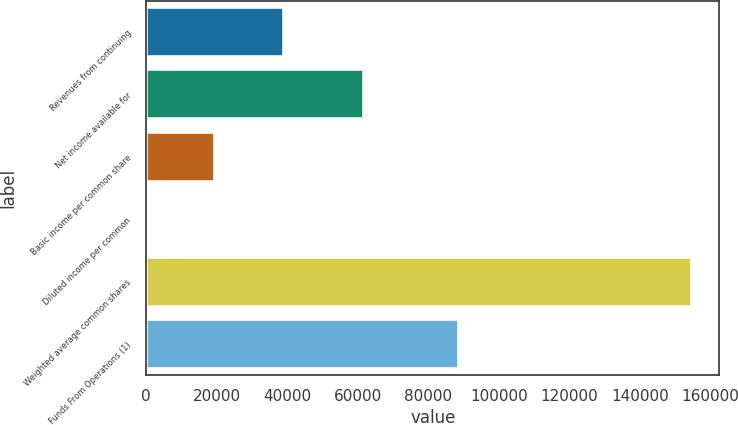Convert chart. <chart><loc_0><loc_0><loc_500><loc_500><bar_chart><fcel>Revenues from continuing<fcel>Net income available for<fcel>Basic income per common share<fcel>Diluted income per common<fcel>Weighted average common shares<fcel>Funds From Operations (1)<nl><fcel>39123.2<fcel>61734<fcel>19561.8<fcel>0.45<fcel>154678<fcel>88787<nl></chart> 